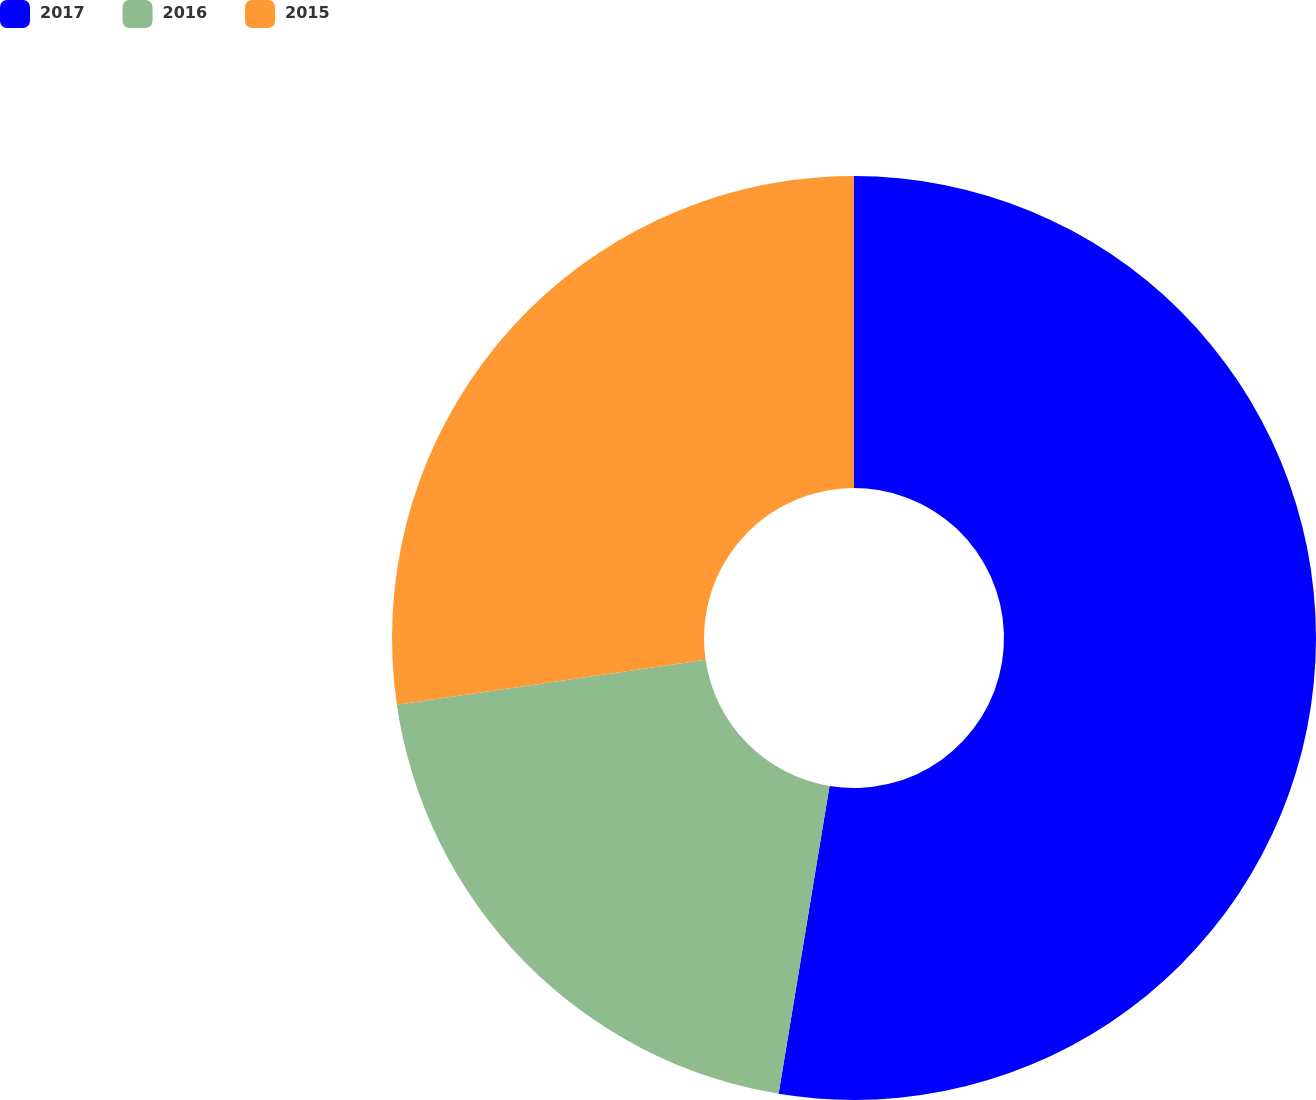<chart> <loc_0><loc_0><loc_500><loc_500><pie_chart><fcel>2017<fcel>2016<fcel>2015<nl><fcel>52.61%<fcel>20.08%<fcel>27.31%<nl></chart> 